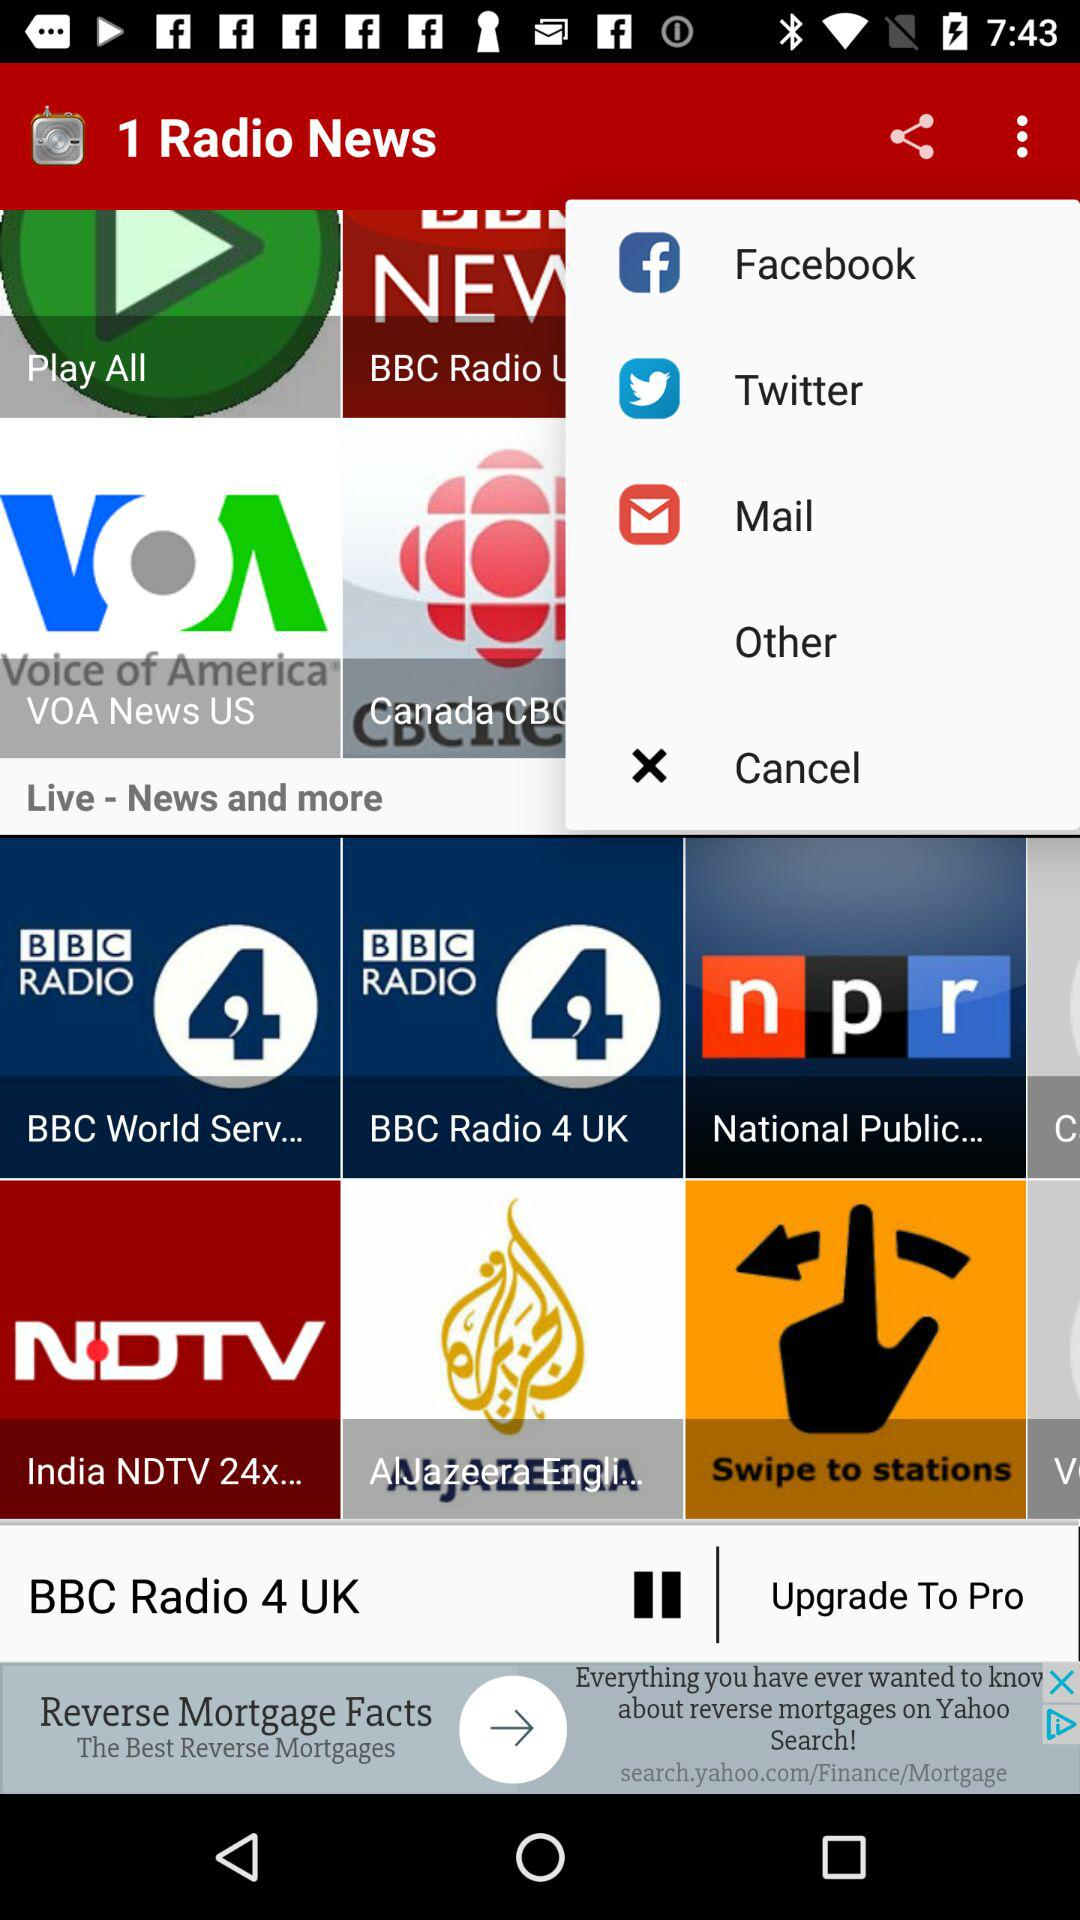What is the application name? The application name is "1 Radio News". 